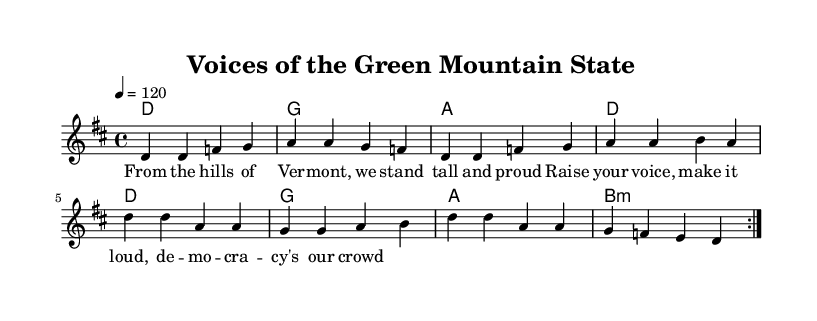What is the key signature of this music? The key signature is D major, which has two sharps: F# and C#.
Answer: D major What is the time signature of this music? The time signature is 4/4, indicating four beats per measure.
Answer: 4/4 What is the tempo marking in this sheet music? The tempo marking indicates a speed of 120 beats per minute, with a quarter note getting one beat.
Answer: 120 How many measures are repeated in the melody? The melody includes two measures that are repeated, as indicated by the "repeat volta 2" directive.
Answer: 2 What type of lyrics does the music feature? The lyrics celebrate democracy and community pride, linking the themes of activism and grassroots efforts from Vermont.
Answer: Activism Which chord is used at the beginning of the second line of harmonies? The chord at the beginning of the second line of harmonies is G major, denoted by the letter "g" in the chord mode.
Answer: G How does the chorus reflect the themes of the song? The chorus calls for raising voices and making democracy a collective effort, emphasizing the importance of community involvement.
Answer: Community involvement 